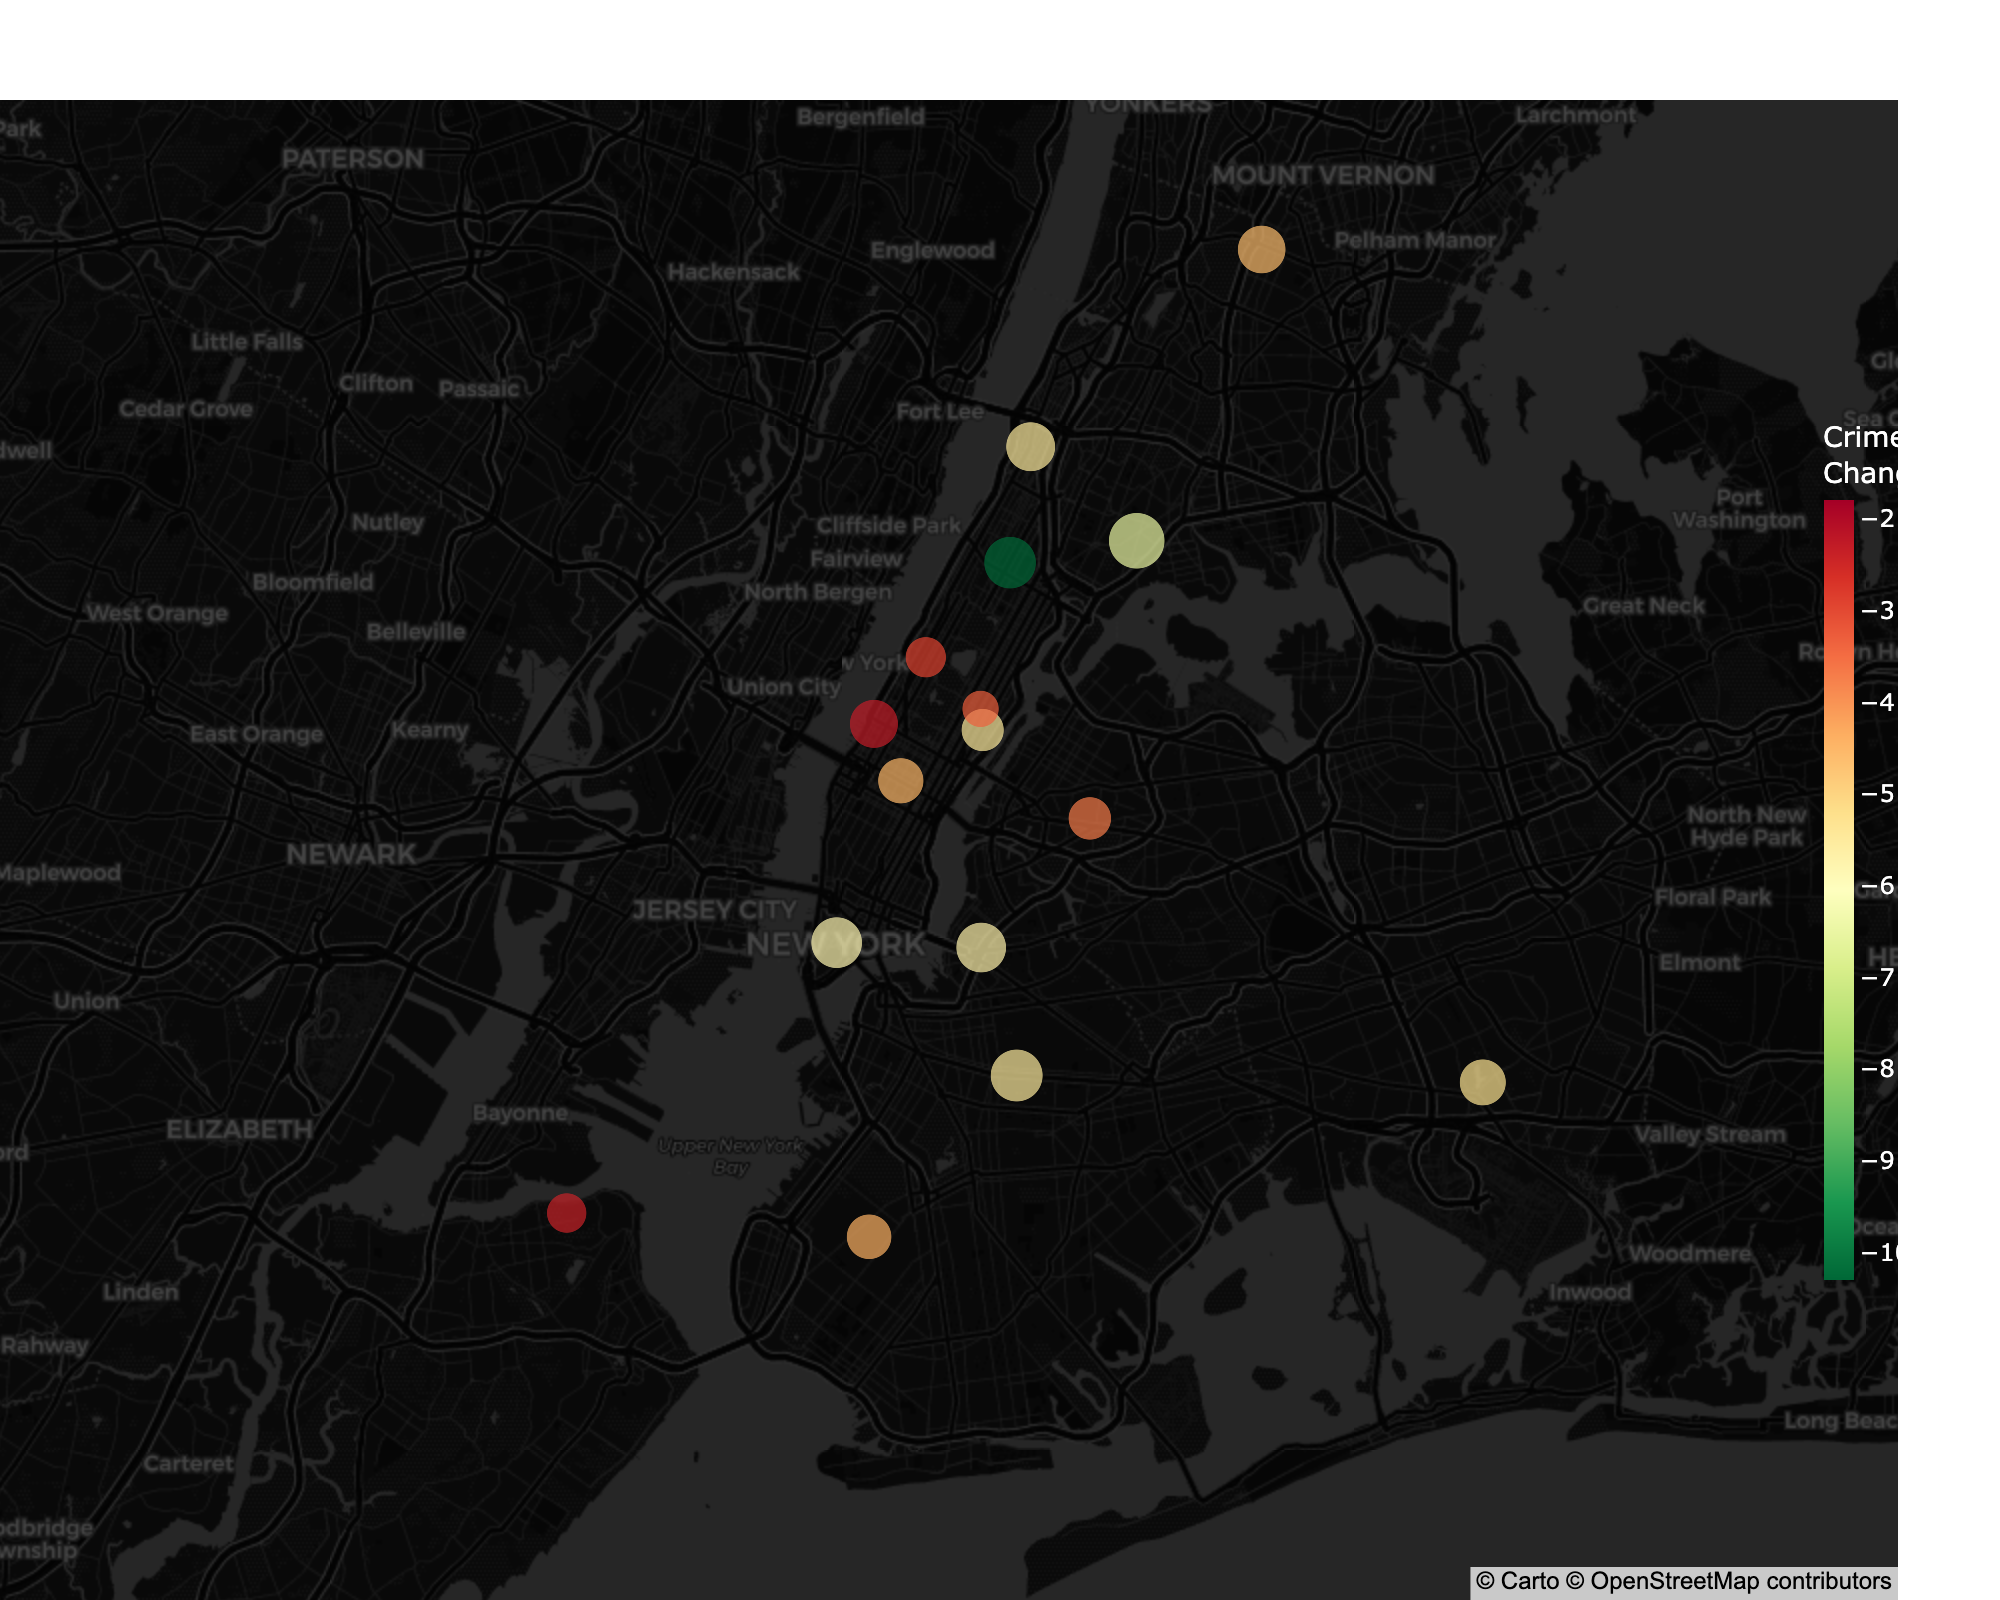What is the title of the map? The title of the map is visually displayed at the top in a larger font size, indicating the purpose of the map.
Answer: NYC Crime Rate Changes (2013-2023) Which district has the highest crime rate in 2023? The district with the largest circle represents the highest crime rate in 2023.
Answer: South Bronx Did the crime rate increase or decrease in Harlem from 2013 to 2023? By looking at the color scale, if Harlem's circle color is towards the red end, it decreased; if it is towards the green end, it increased.
Answer: Decrease Which district showed the largest drop in crime rate over the decade? The color with the deepest red shade represents the largest drop in crime rate.
Answer: South Bronx What's the difference in crime rates between Downtown and Midtown in 2023? Refer to the hover data for both districts and subtract Midtown's crime rate from Downtown's.
Answer: 76.5 - 61.2 = 15.3 Which district has a nearly stable crime rate change over the decade? A district with a color close to yellow signifies a minimal change in crime rates.
Answer: Staten Island North Which districts are located in the northwest part of the map? Identify districts positioned towards the top-left based on latitude and longitude coordinates.
Answer: East Side, Midtown, Downtown, North Bronx, Central Brooklyn, North Brooklyn How many districts have a crime rate decrease of more than 10 points? Count the circles that are deeply in the red range (greater negative change).
Answer: 5 districts (Harlem, South Bronx, Central Brooklyn, North Brooklyn, Southeast Queens) Is the crime rate higher in Upper East Side or Upper West Side in 2023? Compare the circle sizes tagged with Upper East Side and Upper West Side districts.
Answer: Upper West Side What's the average crime rate across all districts in 2023? Sum all the crime rates for 2023 and divide by the number of districts.
Answer: (76.5 + 61.2 + 53.4 + 68.9 + 39.8 + 48.7 + 79.2 + 71.3 + 91.7 + 67.8 + 80.1 + 59.5 + 73.6 + 63.2 + 54.1 + 46.8 + 39.7) / 17 ≈ 63.29 